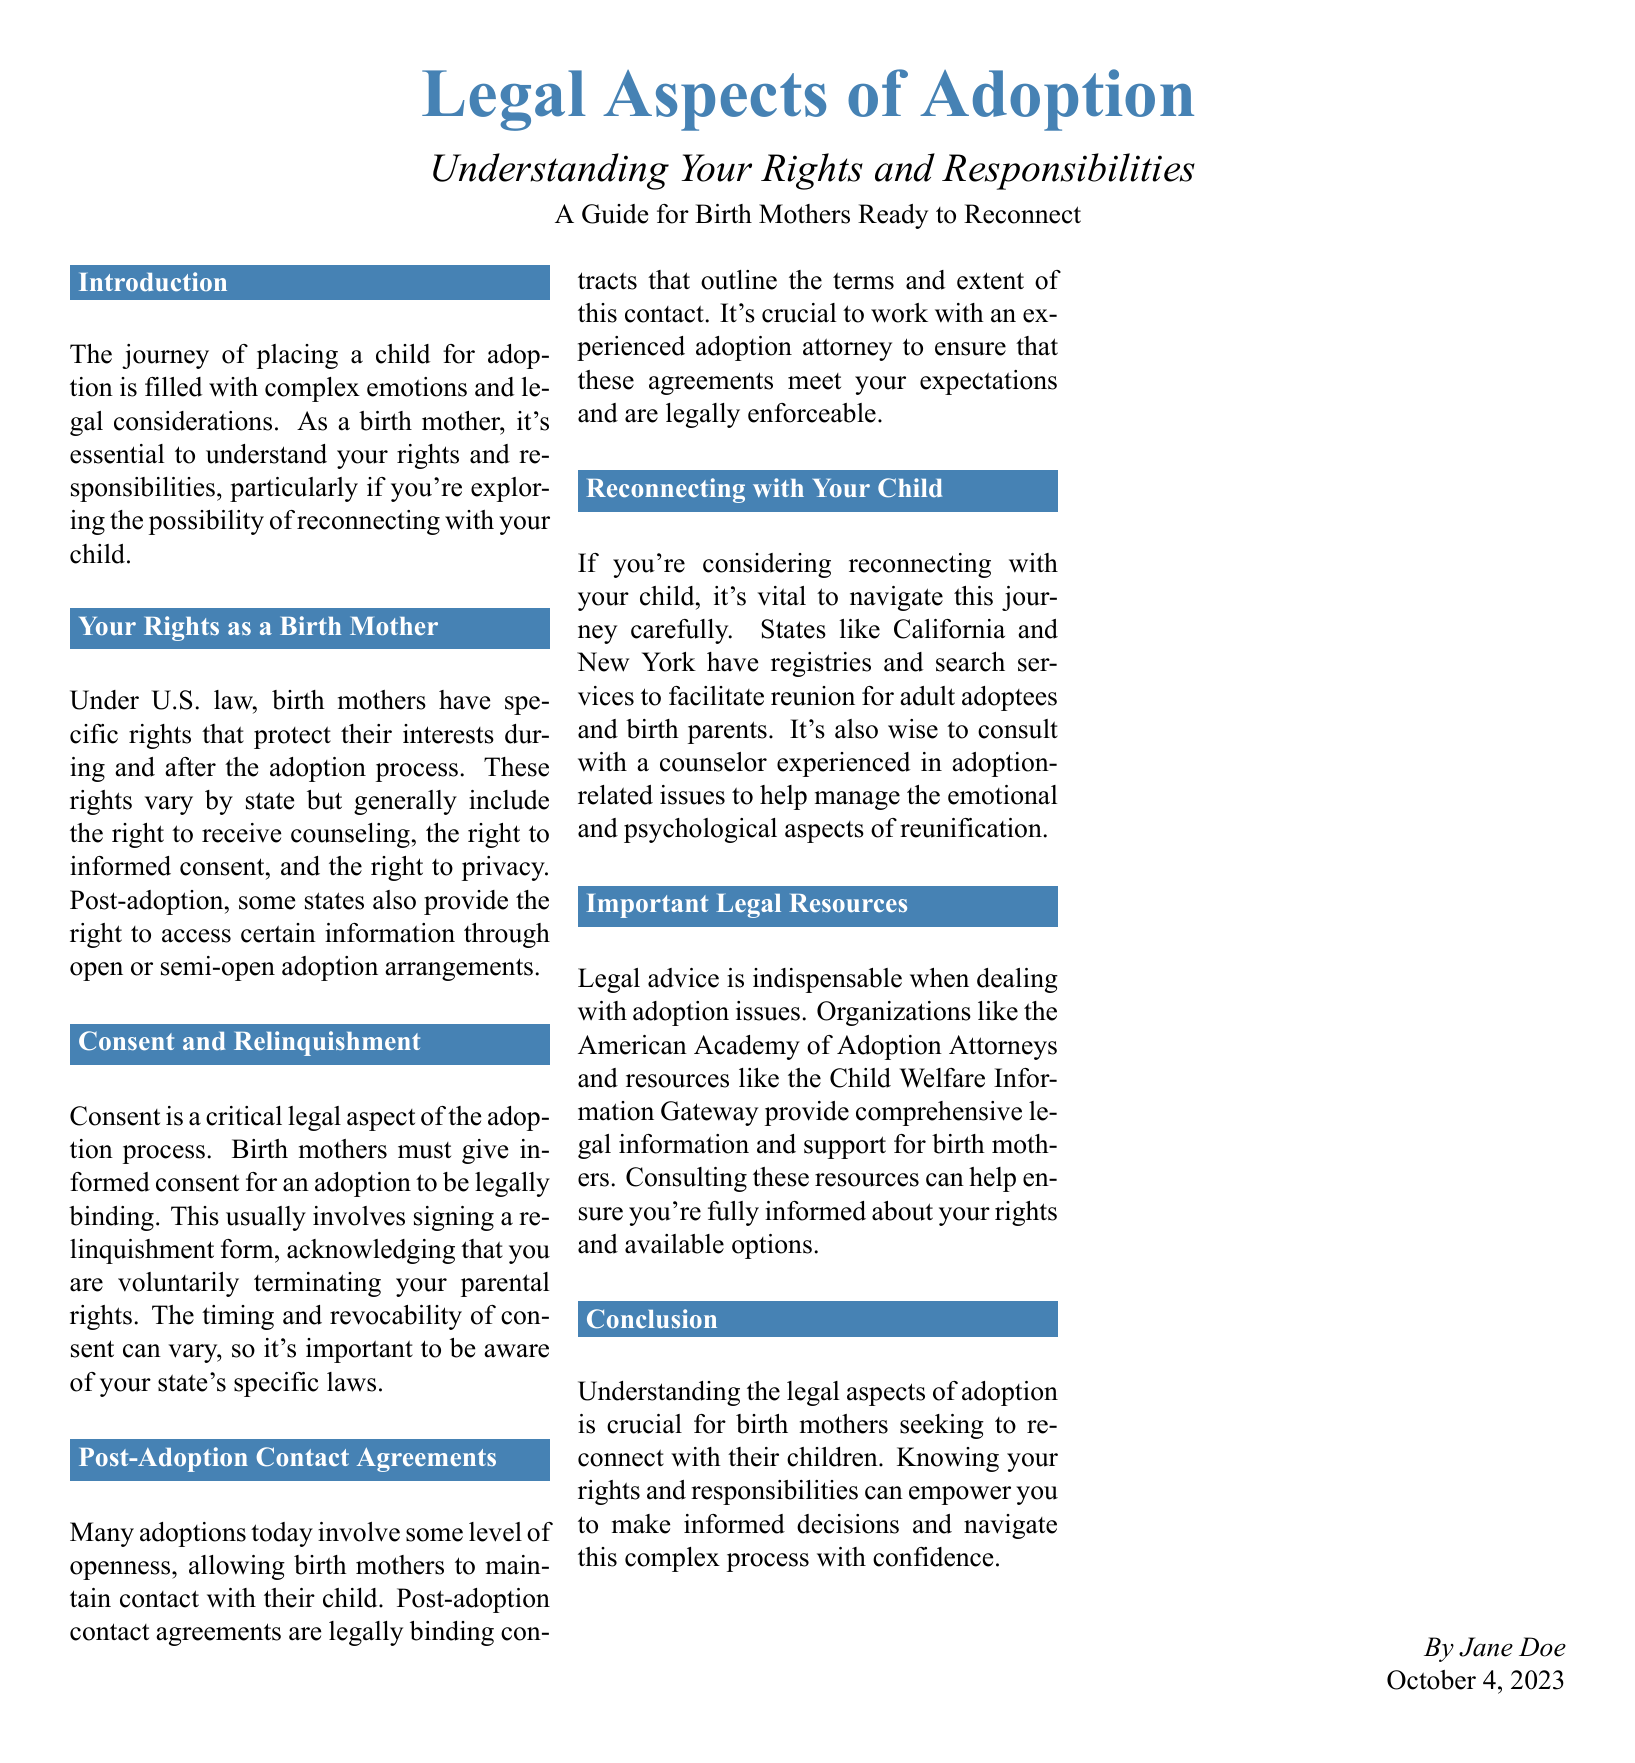What is the title of the document? The title is presented prominently at the beginning of the document, indicating the focus of the content.
Answer: Legal Aspects of Adoption What is the subtitle of the document? The subtitle provides additional context about the main title, indicating the document's intent.
Answer: Understanding Your Rights and Responsibilities Who authored the document? The author's name is typically found at the end of the document, providing credit for the content.
Answer: Jane Doe What date was the document published? The publication date is often included to indicate when the information was made available to the public.
Answer: October 4, 2023 What are two rights of birth mothers mentioned? This question requires knowledge of specific content within the section about rights.
Answer: Counseling and Informed Consent What is a critical legal aspect of the adoption process mentioned? This question is based on the section regarding consent and relinquishment in the adoption journey.
Answer: Informed Consent What do post-adoption contact agreements define? This question relates to the information about maintaining contact after adoption.
Answer: Terms and extent of contact Which states are mentioned as having registries for reconnecting? The question focuses on specific examples of states related to the topic of reconnecting with children.
Answer: California and New York What is the purpose of consulting with an experienced adoption attorney? This question requires knowledge of the importance of legal advice in the adoption process, mentioned in the relevant section.
Answer: Ensure agreements are legally enforceable 